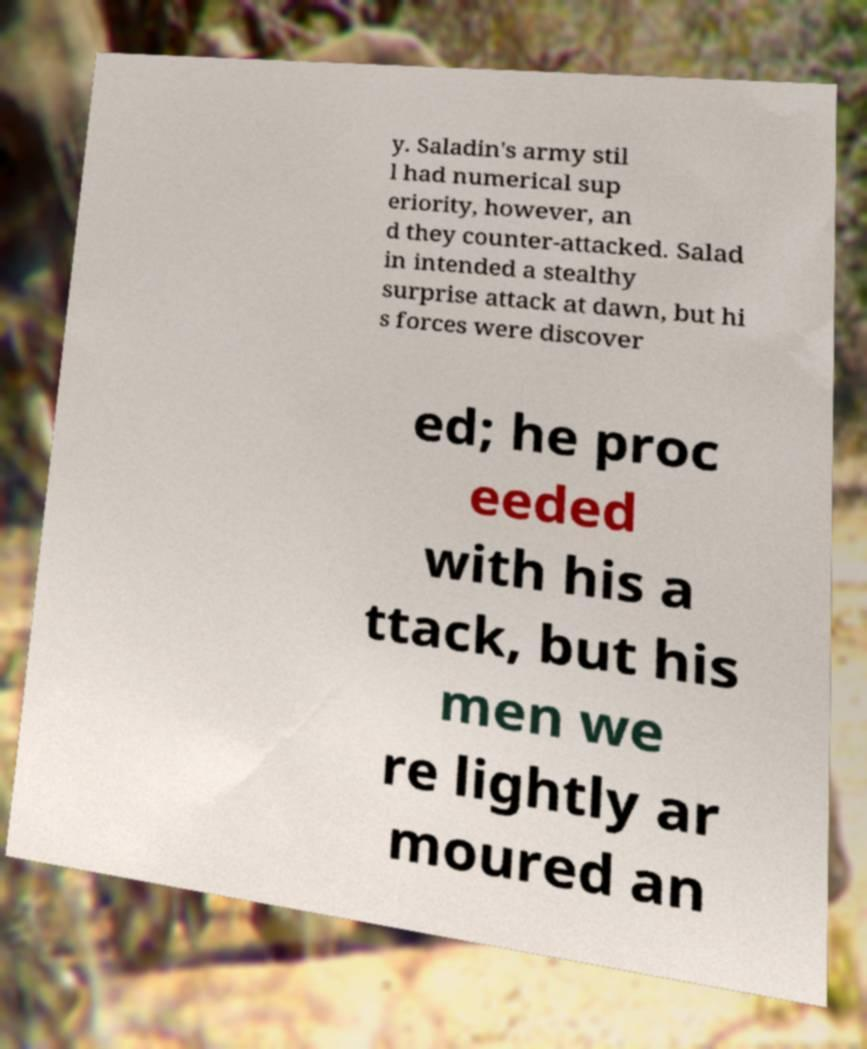What messages or text are displayed in this image? I need them in a readable, typed format. y. Saladin's army stil l had numerical sup eriority, however, an d they counter-attacked. Salad in intended a stealthy surprise attack at dawn, but hi s forces were discover ed; he proc eeded with his a ttack, but his men we re lightly ar moured an 